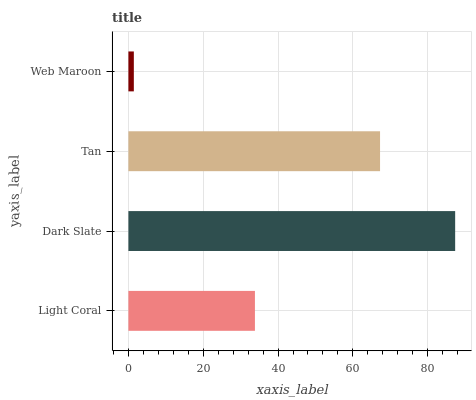Is Web Maroon the minimum?
Answer yes or no. Yes. Is Dark Slate the maximum?
Answer yes or no. Yes. Is Tan the minimum?
Answer yes or no. No. Is Tan the maximum?
Answer yes or no. No. Is Dark Slate greater than Tan?
Answer yes or no. Yes. Is Tan less than Dark Slate?
Answer yes or no. Yes. Is Tan greater than Dark Slate?
Answer yes or no. No. Is Dark Slate less than Tan?
Answer yes or no. No. Is Tan the high median?
Answer yes or no. Yes. Is Light Coral the low median?
Answer yes or no. Yes. Is Web Maroon the high median?
Answer yes or no. No. Is Web Maroon the low median?
Answer yes or no. No. 